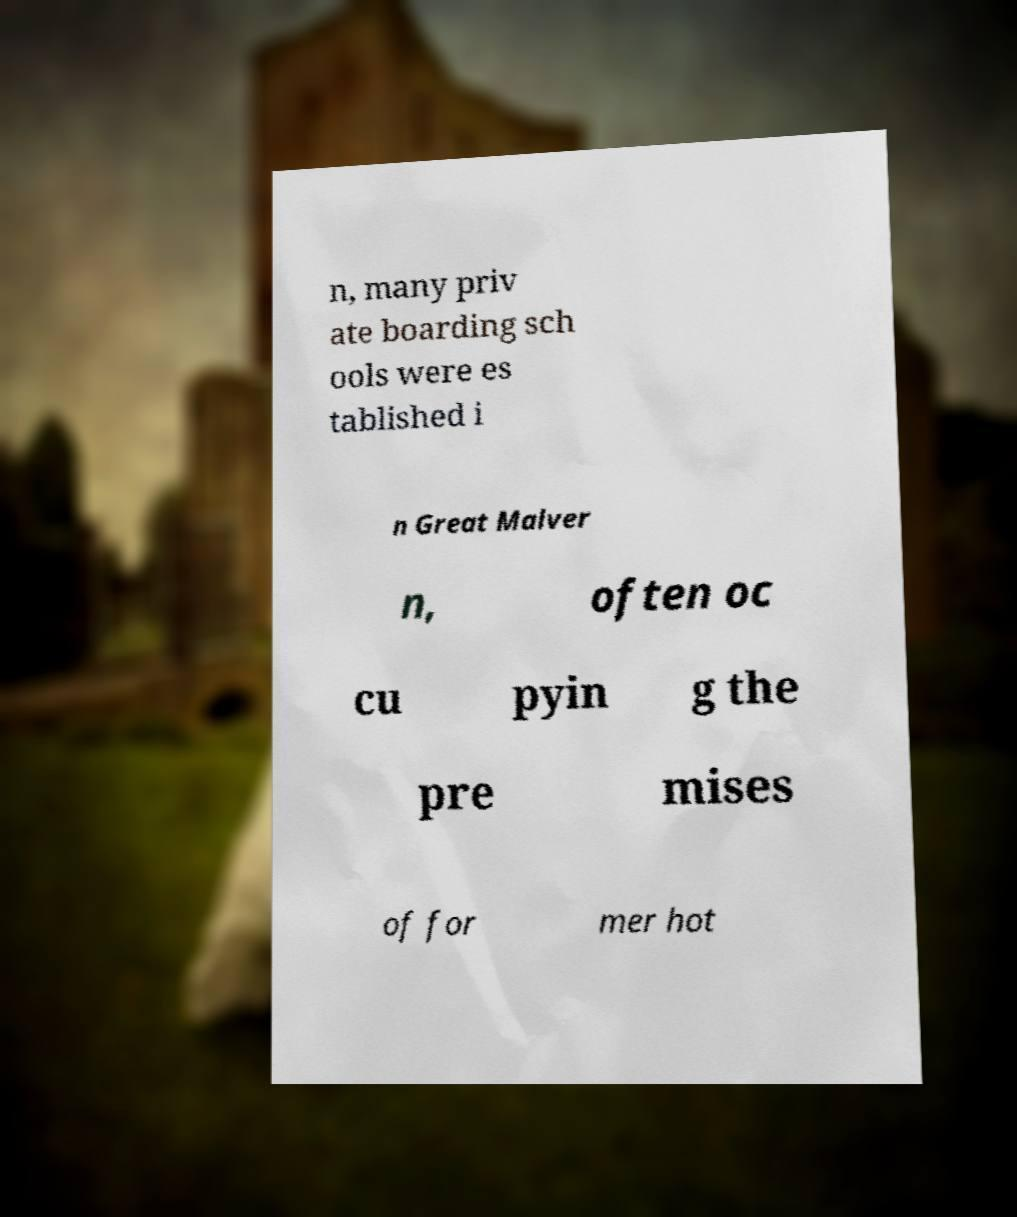Could you extract and type out the text from this image? n, many priv ate boarding sch ools were es tablished i n Great Malver n, often oc cu pyin g the pre mises of for mer hot 